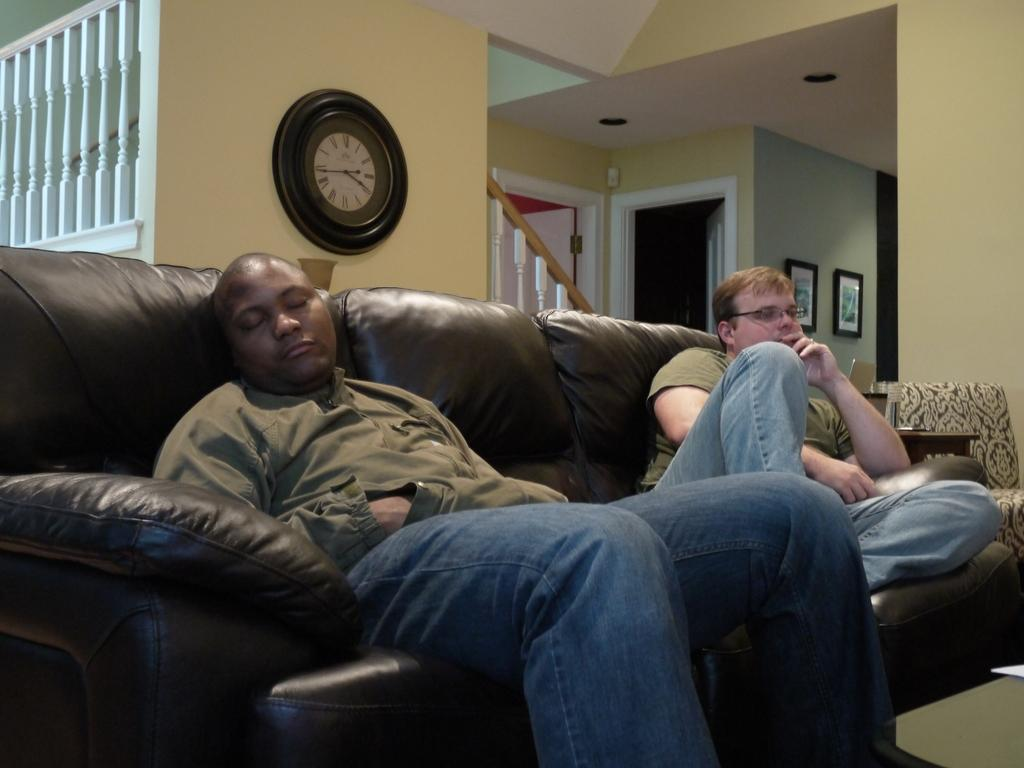How many people are in the image? There are two men in the image. What are the men doing in the image? The men are sitting on a couch. Can you describe the condition of the man on the left? The man on the left is sleeping. What time-telling device is visible in the image? There is a wall clock visible in the image. What architectural features can be seen in the image? There is a staircase and a door present in the image. What type of pump is being used by the actor in the image? There is no actor or pump present in the image. 